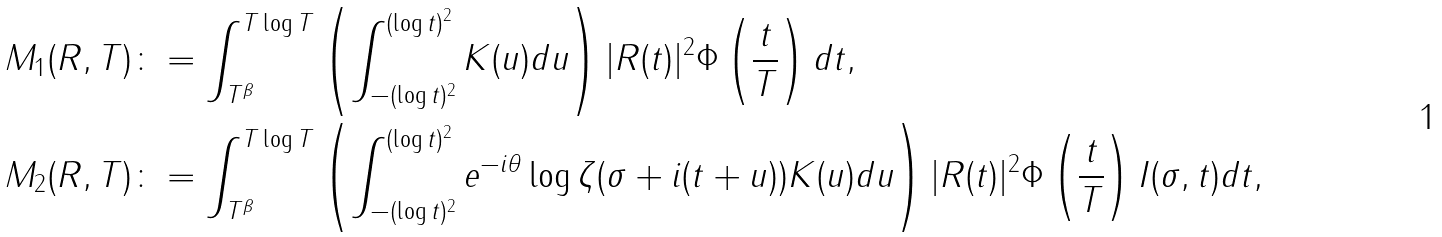<formula> <loc_0><loc_0><loc_500><loc_500>M _ { 1 } ( R , T ) & \colon = \int _ { T ^ { \beta } } ^ { T \log { T } } \left ( \int _ { - ( \log { t } ) ^ { 2 } } ^ { ( \log { t } ) ^ { 2 } } K ( u ) d u \right ) | R ( t ) | ^ { 2 } \Phi \left ( \frac { t } { T } \right ) d t , \\ M _ { 2 } ( R , T ) & \colon = \int _ { T ^ { \beta } } ^ { T \log { T } } \left ( \int _ { - ( \log { t } ) ^ { 2 } } ^ { ( \log { t } ) ^ { 2 } } e ^ { - i \theta } \log \zeta ( \sigma + i ( t + u ) ) K ( u ) d u \right ) | R ( t ) | ^ { 2 } \Phi \left ( \frac { t } { T } \right ) I ( \sigma , t ) d t ,</formula> 